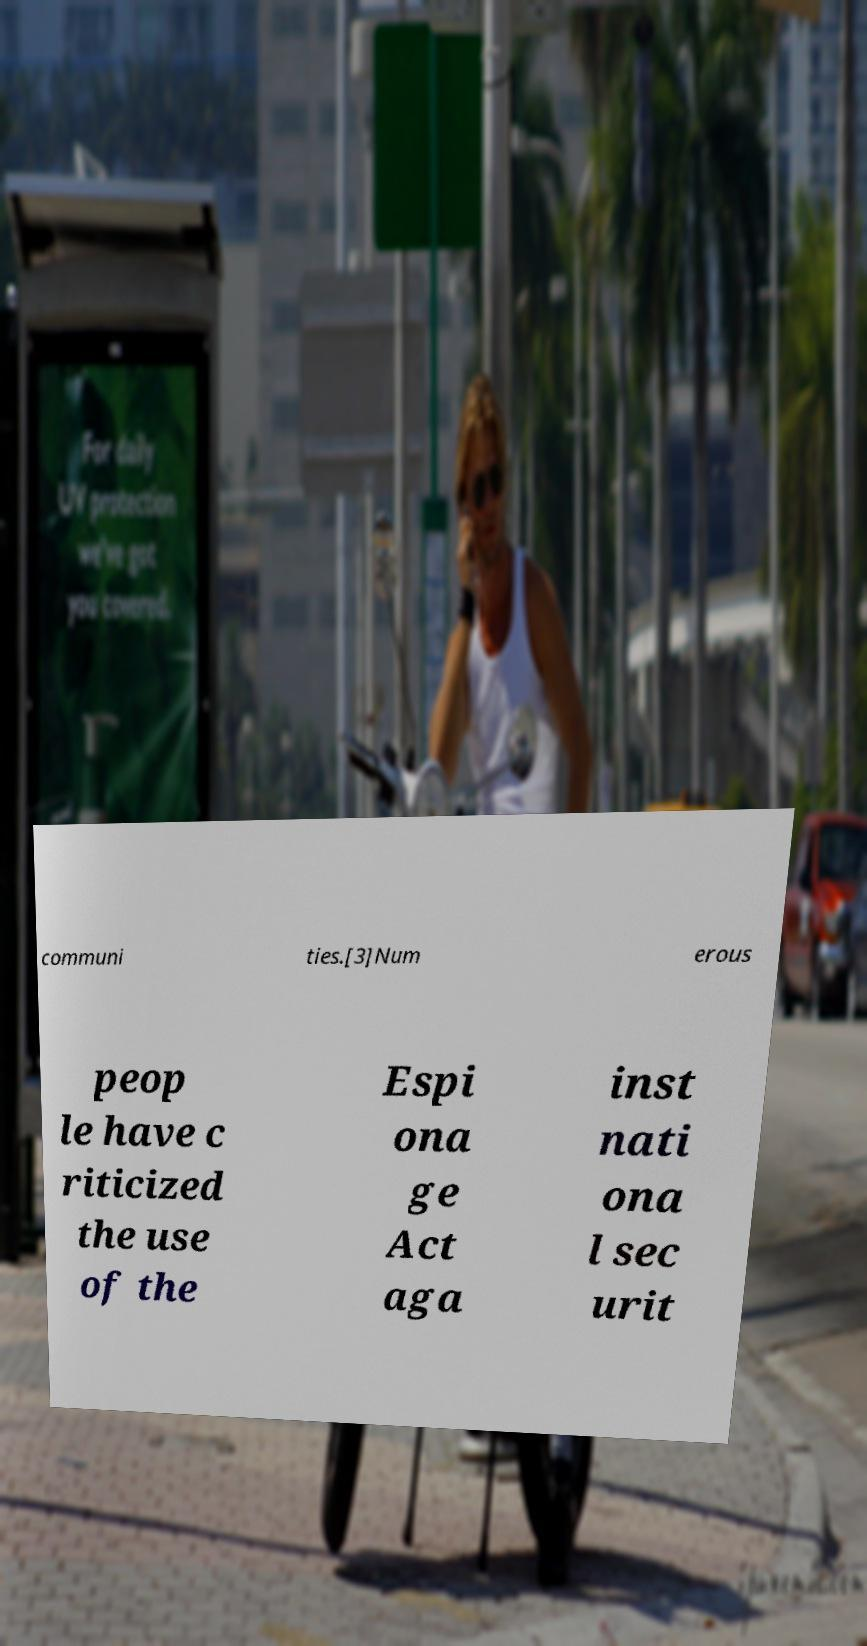Can you read and provide the text displayed in the image?This photo seems to have some interesting text. Can you extract and type it out for me? communi ties.[3]Num erous peop le have c riticized the use of the Espi ona ge Act aga inst nati ona l sec urit 